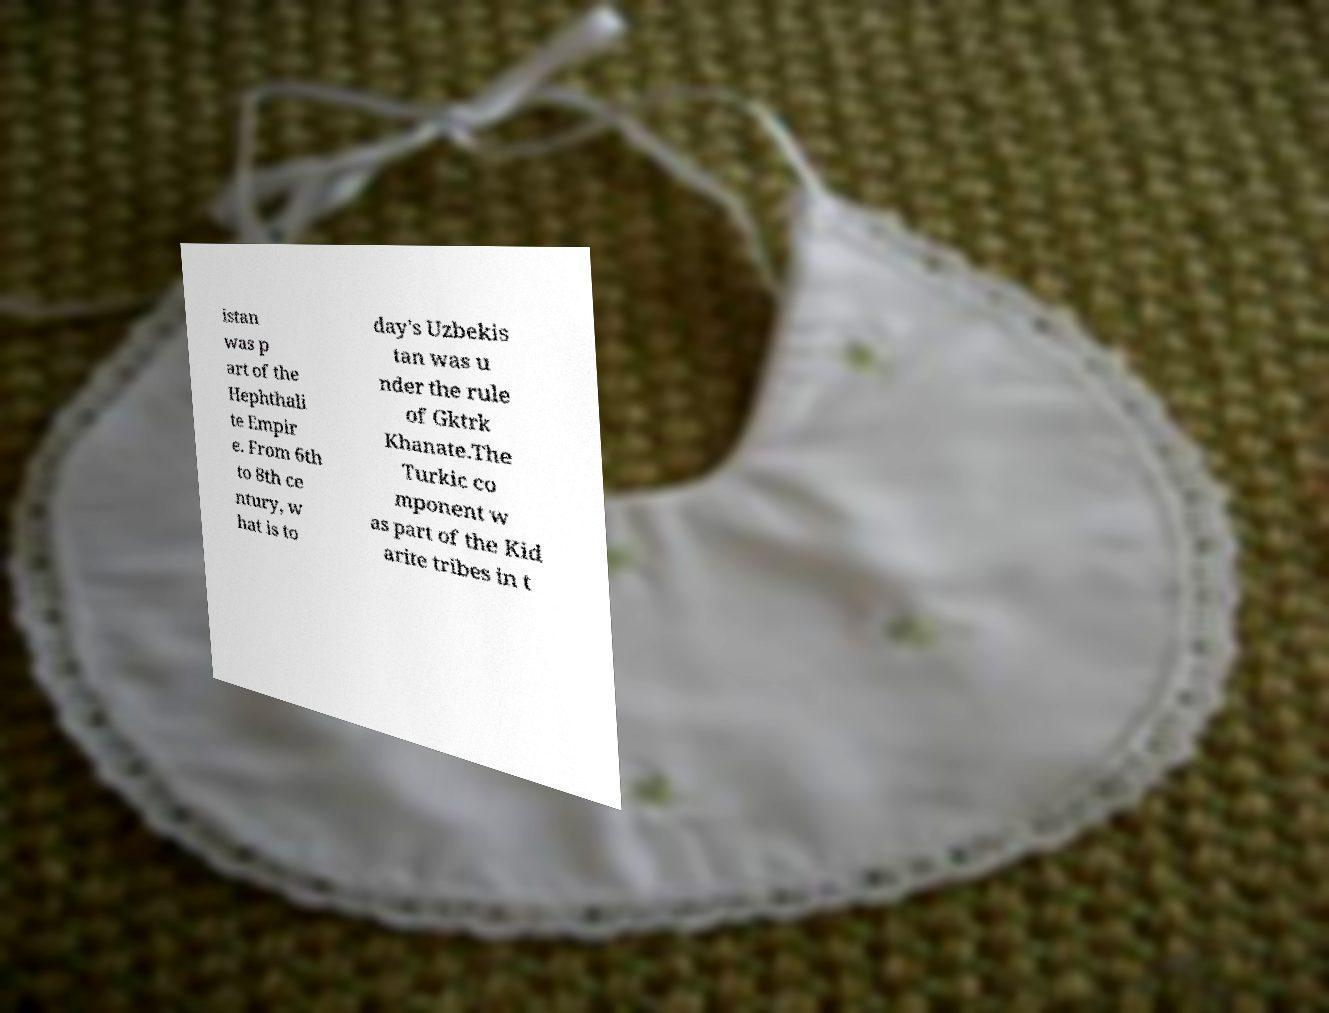Please read and relay the text visible in this image. What does it say? istan was p art of the Hephthali te Empir e. From 6th to 8th ce ntury, w hat is to day's Uzbekis tan was u nder the rule of Gktrk Khanate.The Turkic co mponent w as part of the Kid arite tribes in t 